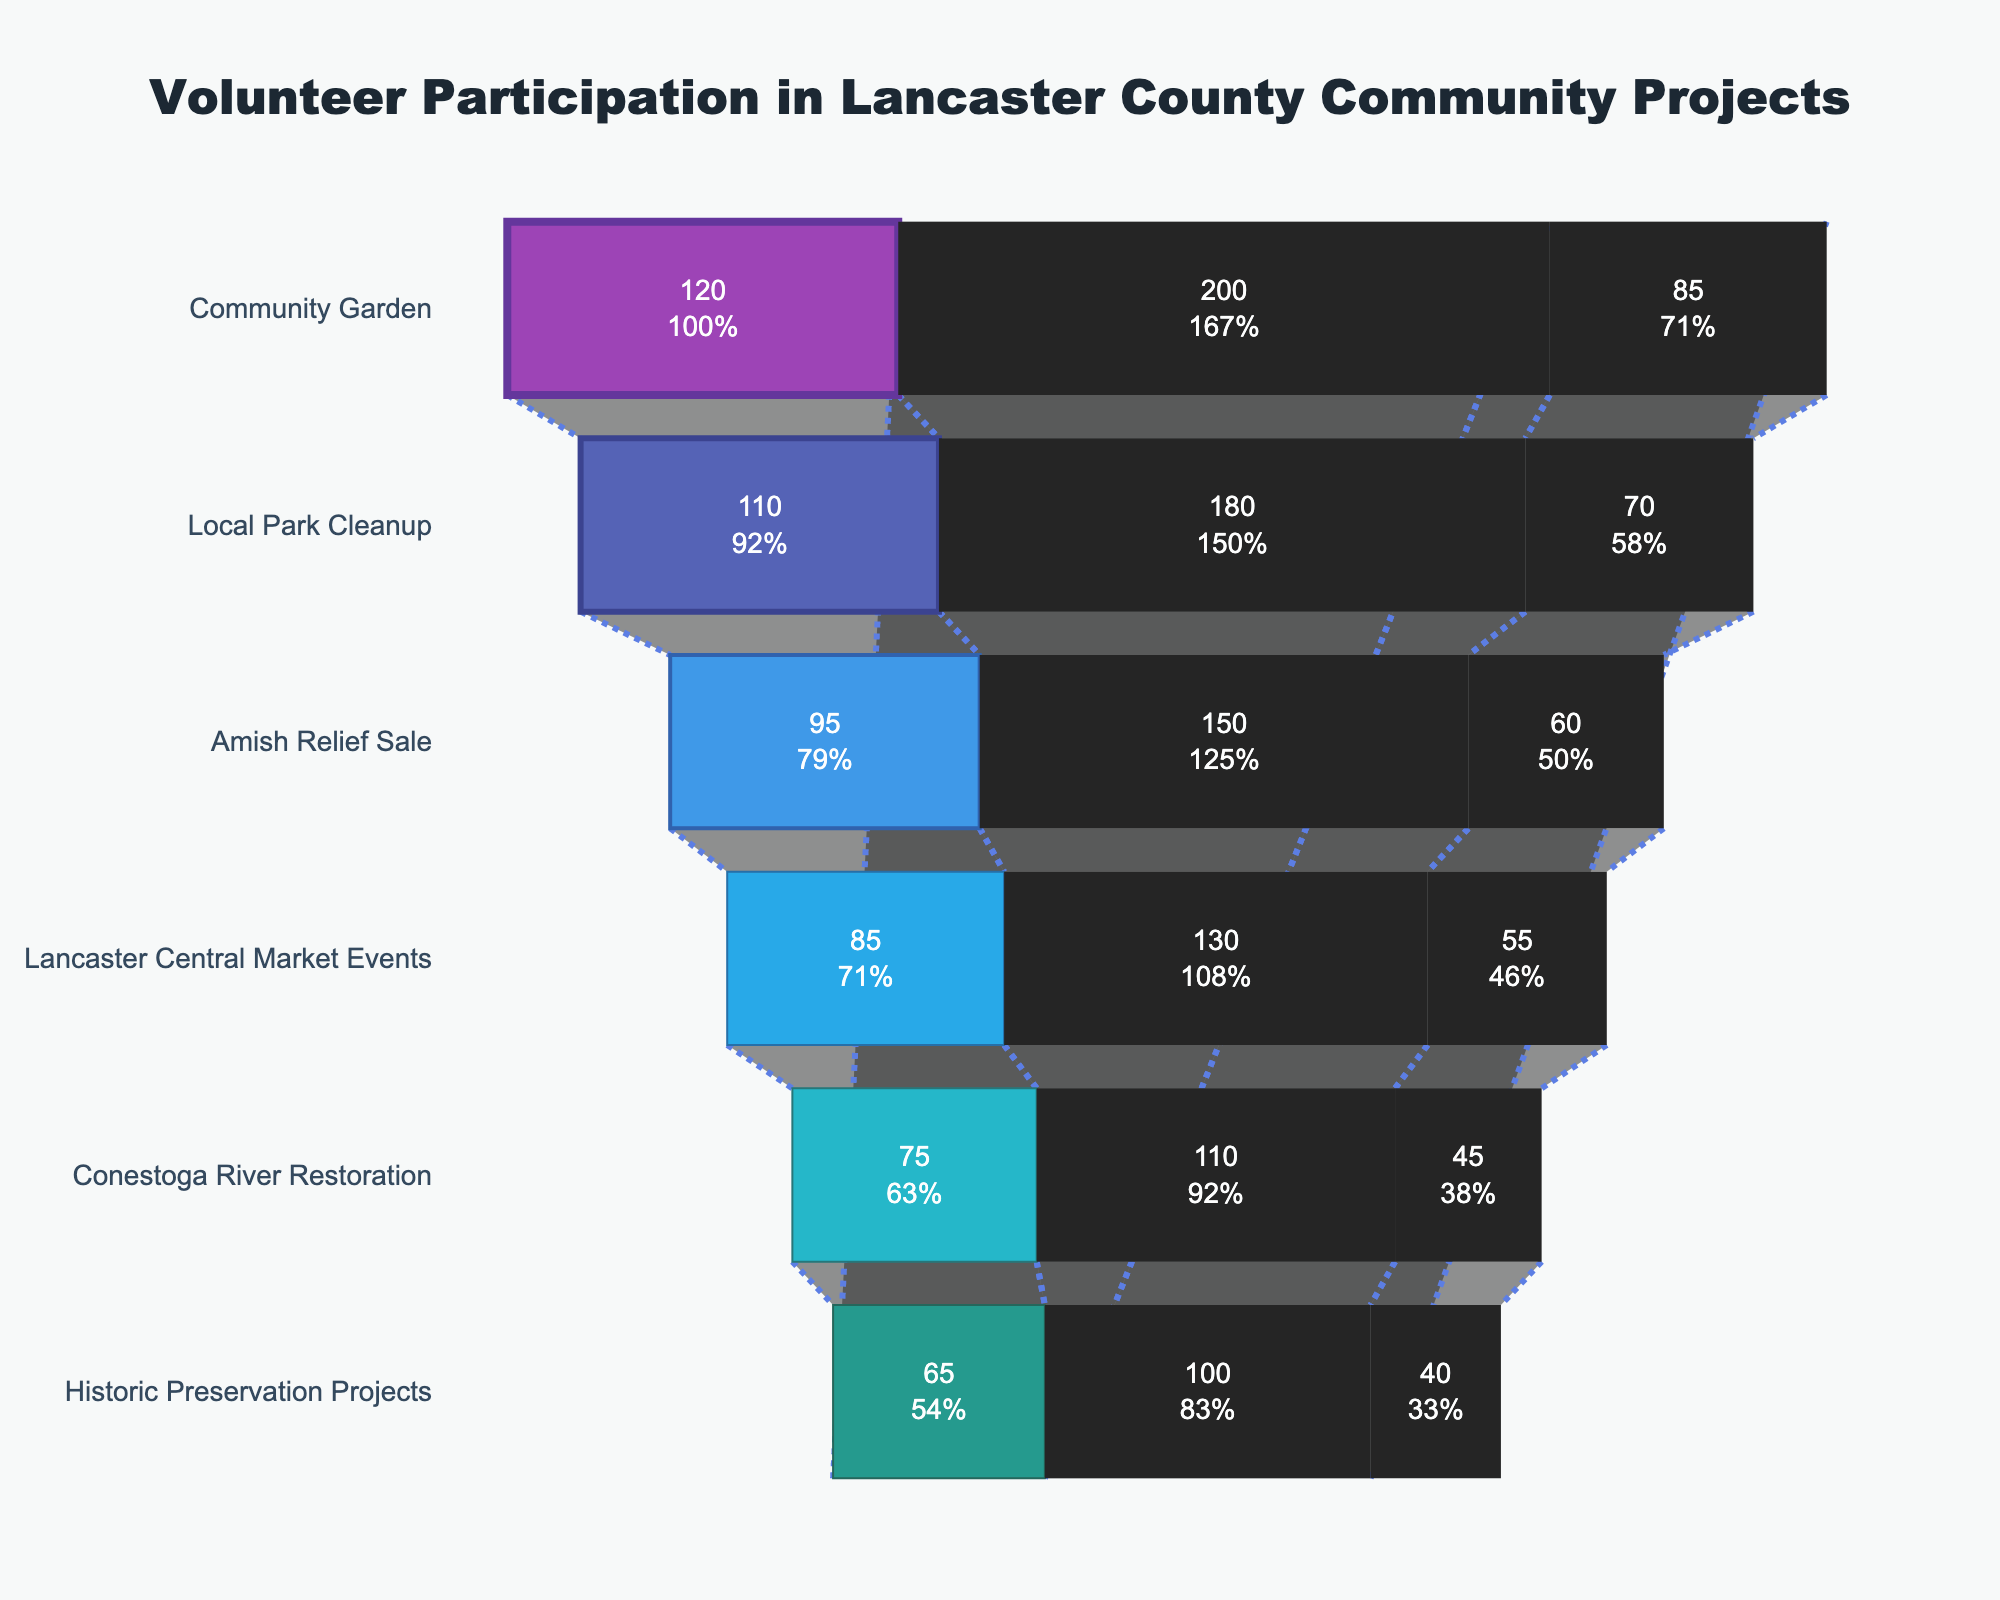What is the title of the funnel chart? The chart has a clear title located at the top center of the figure.
Answer: "Volunteer Participation in Lancaster County Community Projects" Which project type has the highest number of high commitment volunteers? The highest number in the High Commitment category can be found by locating the bar with the largest length in the respective section.
Answer: Community Garden How many levels of commitment are represented in the chart? There are distinct sections in each bar representing different levels. These can be counted to determine the number of levels.
Answer: 3 Which project type has the lowest participation in any commitment level? To find this, look for the smallest segment in any of the bars representing the commitment levels.
Answer: Historic Preservation Projects What is the total number of Medium Commitment volunteers across all project types? Add the number of Medium Commitment participants across all the project types: 120 + 110 + 95 + 85 + 75 + 65.
Answer: 550 Which project type has the smallest difference between High and Medium Commitment volunteers? Calculate the difference between High and Medium Commitment volunteers for each project and compare which is smallest. The differences are: Community Garden (120-85 = 35), Local Park Cleanup (110-70 = 40), Amish Relief Sale (95-60 = 35), Lancaster Central Market Events (85-55 = 30), Conestoga River Restoration (75-45 = 30), Historic Preservation Projects (65-40 = 25).
Answer: Historic Preservation Projects How does the participation in Lancaster Central Market Events compare in High and Low Commitment levels? Compare the values of the corresponding segments: High Commitment (55) and Low Commitment (130) for Lancaster Central Market Events.
Answer: Low Commitment is higher Which project has the highest percentage of participants in the Low Commitment level relative to the total participants in that project? Calculate the percentage of Low Commitment participants for each project: (Low Commitment / (High Commitment + Medium Commitment + Low Commitment)) and find the highest. Percentages are: Community Garden (200/(85+120+200) ≈ 47%), Local Park Cleanup (180/(70+110+180) ≈ 46%), Amish Relief Sale (150/(60+95+150) ≈ 48%), Lancaster Central Market Events (130/(55+85+130) ≈ 47%), Conestoga River Restoration (110/(45+75+110) ≈ 46%), Historic Preservation Projects (100/(40+65+100) ≈ 47%).
Answer: Amish Relief Sale What is the total number of participants in the Conestoga River Restoration project across all commitment levels? Sum the participants in each commitment level for Conestoga River Restoration: 45 + 75 + 110.
Answer: 230 What is the color of the bar representing the Community Garden project in the funnel chart? Look at the color of the bar segment associated with Community Garden project.
Answer: Purple 